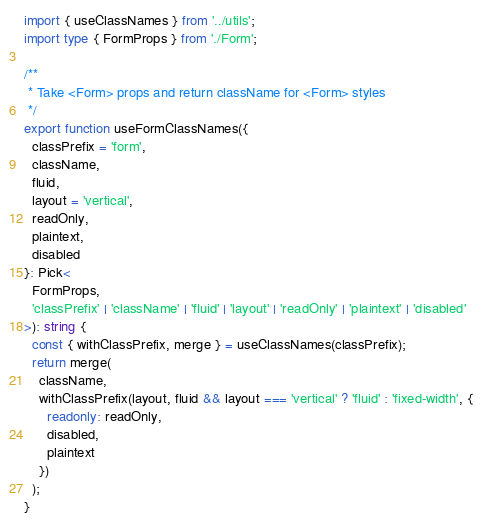Convert code to text. <code><loc_0><loc_0><loc_500><loc_500><_TypeScript_>import { useClassNames } from '../utils';
import type { FormProps } from './Form';

/**
 * Take <Form> props and return className for <Form> styles
 */
export function useFormClassNames({
  classPrefix = 'form',
  className,
  fluid,
  layout = 'vertical',
  readOnly,
  plaintext,
  disabled
}: Pick<
  FormProps,
  'classPrefix' | 'className' | 'fluid' | 'layout' | 'readOnly' | 'plaintext' | 'disabled'
>): string {
  const { withClassPrefix, merge } = useClassNames(classPrefix);
  return merge(
    className,
    withClassPrefix(layout, fluid && layout === 'vertical' ? 'fluid' : 'fixed-width', {
      readonly: readOnly,
      disabled,
      plaintext
    })
  );
}
</code> 